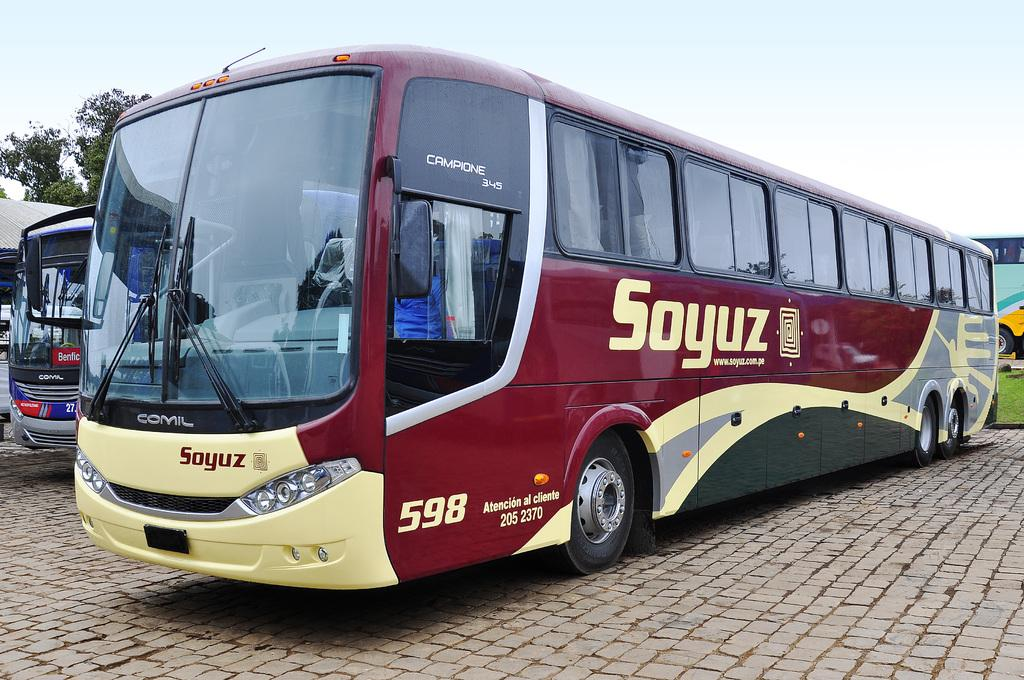What type of vehicles are on the ground in the image? There are buses on the ground in the image. What is located on the left side of the image? There is a roof and a tree on the left side of the image. What is visible at the top of the image? The sky is visible at the top of the image. How many thumbs can be seen holding the buses in the image? There are no thumbs visible in the image, as it features buses on the ground and other objects in the scene. 